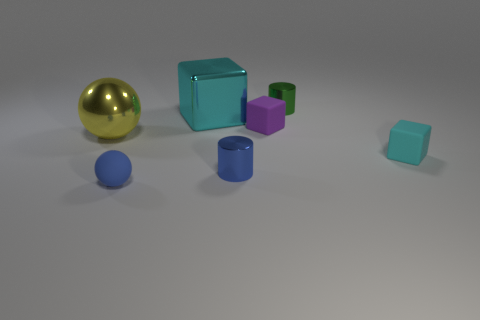Subtract all green cylinders. How many cyan blocks are left? 2 Subtract all tiny rubber blocks. How many blocks are left? 1 Add 3 small blue metallic cylinders. How many objects exist? 10 Subtract all cylinders. How many objects are left? 5 Subtract all gray blocks. Subtract all yellow balls. How many blocks are left? 3 Add 6 large things. How many large things exist? 8 Subtract 0 yellow cubes. How many objects are left? 7 Subtract all blue cylinders. Subtract all yellow metallic spheres. How many objects are left? 5 Add 2 large blocks. How many large blocks are left? 3 